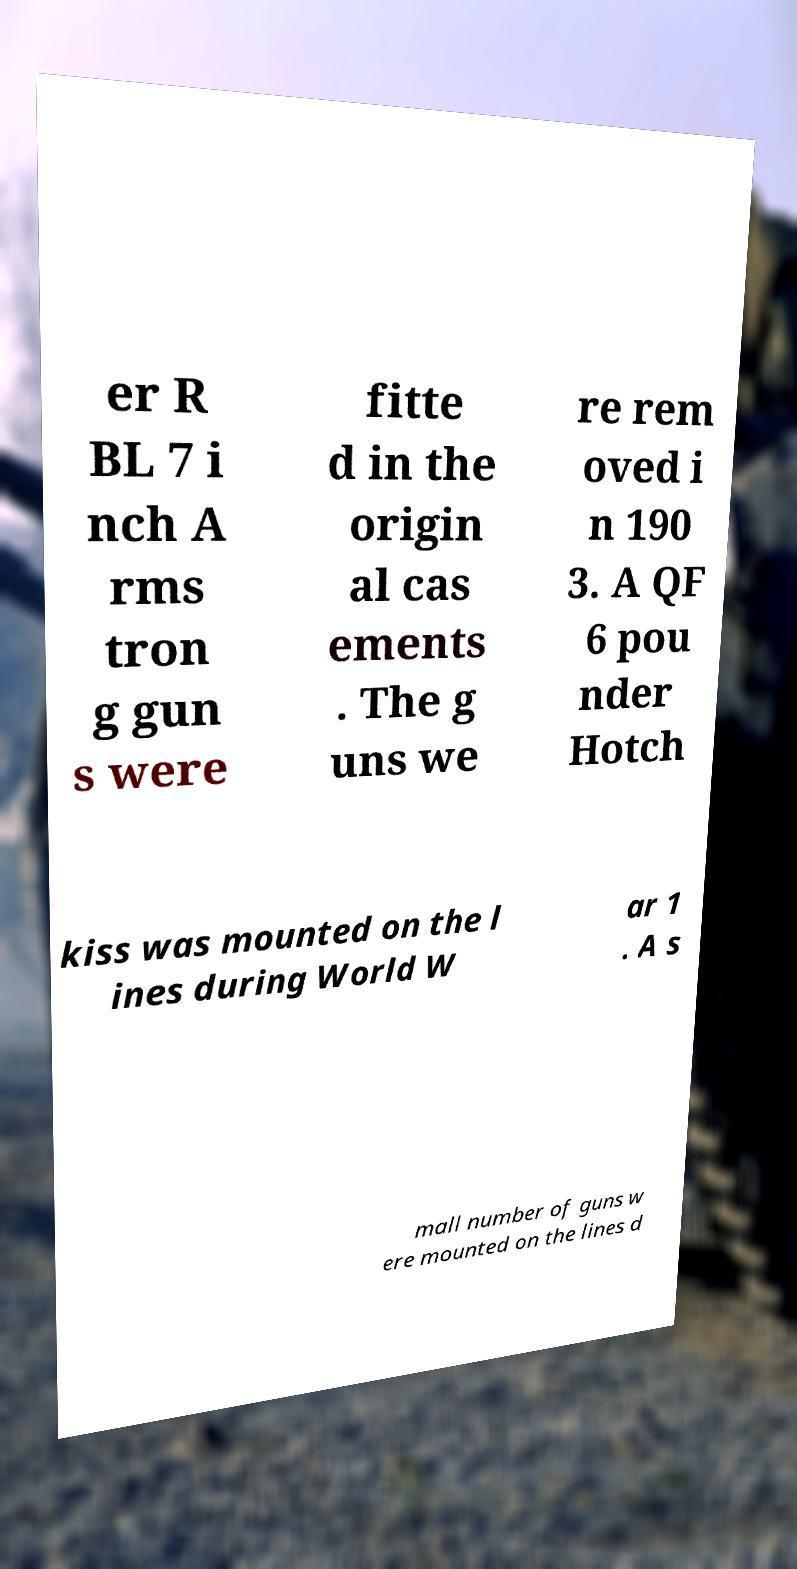There's text embedded in this image that I need extracted. Can you transcribe it verbatim? er R BL 7 i nch A rms tron g gun s were fitte d in the origin al cas ements . The g uns we re rem oved i n 190 3. A QF 6 pou nder Hotch kiss was mounted on the l ines during World W ar 1 . A s mall number of guns w ere mounted on the lines d 